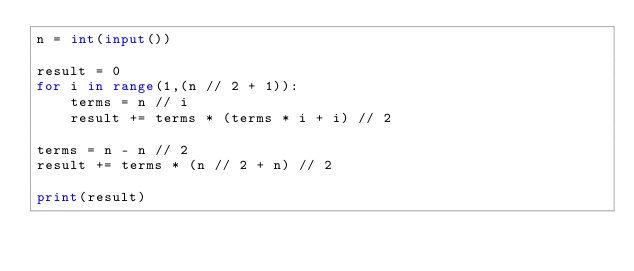Convert code to text. <code><loc_0><loc_0><loc_500><loc_500><_Python_>n = int(input())

result = 0
for i in range(1,(n // 2 + 1)):
    terms = n // i
    result += terms * (terms * i + i) // 2

terms = n - n // 2
result += terms * (n // 2 + n) // 2

print(result)</code> 